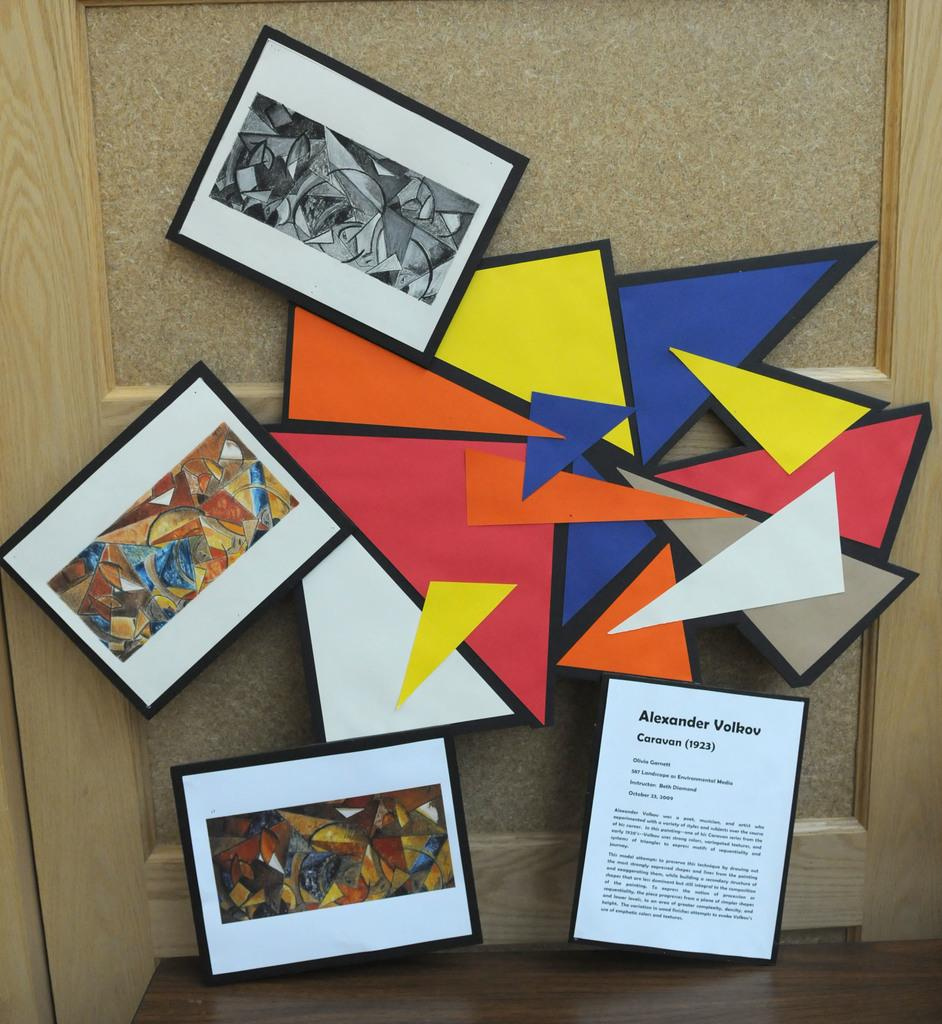Provide a one-sentence caption for the provided image. A colorful display of shapes connecting three framed printed pictures by Alexander Volkov. 